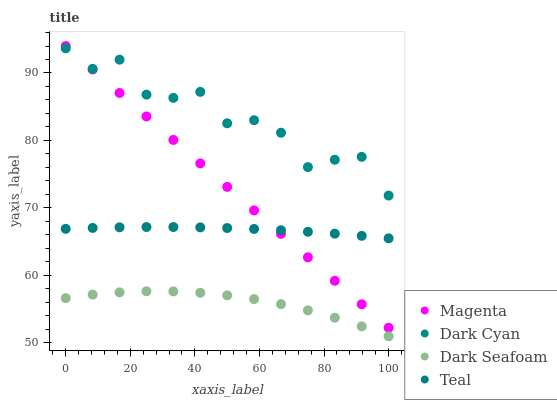Does Dark Seafoam have the minimum area under the curve?
Answer yes or no. Yes. Does Dark Cyan have the maximum area under the curve?
Answer yes or no. Yes. Does Magenta have the minimum area under the curve?
Answer yes or no. No. Does Magenta have the maximum area under the curve?
Answer yes or no. No. Is Magenta the smoothest?
Answer yes or no. Yes. Is Dark Cyan the roughest?
Answer yes or no. Yes. Is Dark Seafoam the smoothest?
Answer yes or no. No. Is Dark Seafoam the roughest?
Answer yes or no. No. Does Dark Seafoam have the lowest value?
Answer yes or no. Yes. Does Magenta have the lowest value?
Answer yes or no. No. Does Magenta have the highest value?
Answer yes or no. Yes. Does Dark Seafoam have the highest value?
Answer yes or no. No. Is Dark Seafoam less than Dark Cyan?
Answer yes or no. Yes. Is Dark Cyan greater than Dark Seafoam?
Answer yes or no. Yes. Does Magenta intersect Teal?
Answer yes or no. Yes. Is Magenta less than Teal?
Answer yes or no. No. Is Magenta greater than Teal?
Answer yes or no. No. Does Dark Seafoam intersect Dark Cyan?
Answer yes or no. No. 